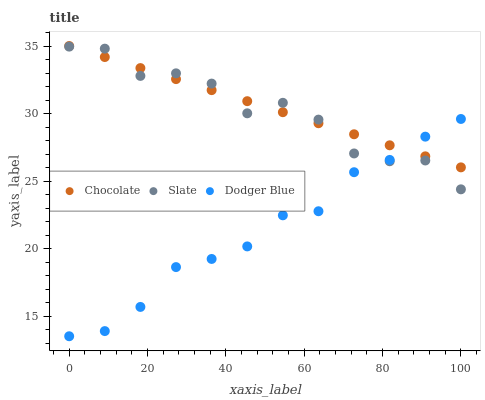Does Dodger Blue have the minimum area under the curve?
Answer yes or no. Yes. Does Chocolate have the maximum area under the curve?
Answer yes or no. Yes. Does Chocolate have the minimum area under the curve?
Answer yes or no. No. Does Dodger Blue have the maximum area under the curve?
Answer yes or no. No. Is Chocolate the smoothest?
Answer yes or no. Yes. Is Slate the roughest?
Answer yes or no. Yes. Is Dodger Blue the smoothest?
Answer yes or no. No. Is Dodger Blue the roughest?
Answer yes or no. No. Does Dodger Blue have the lowest value?
Answer yes or no. Yes. Does Chocolate have the lowest value?
Answer yes or no. No. Does Chocolate have the highest value?
Answer yes or no. Yes. Does Dodger Blue have the highest value?
Answer yes or no. No. Does Chocolate intersect Slate?
Answer yes or no. Yes. Is Chocolate less than Slate?
Answer yes or no. No. Is Chocolate greater than Slate?
Answer yes or no. No. 